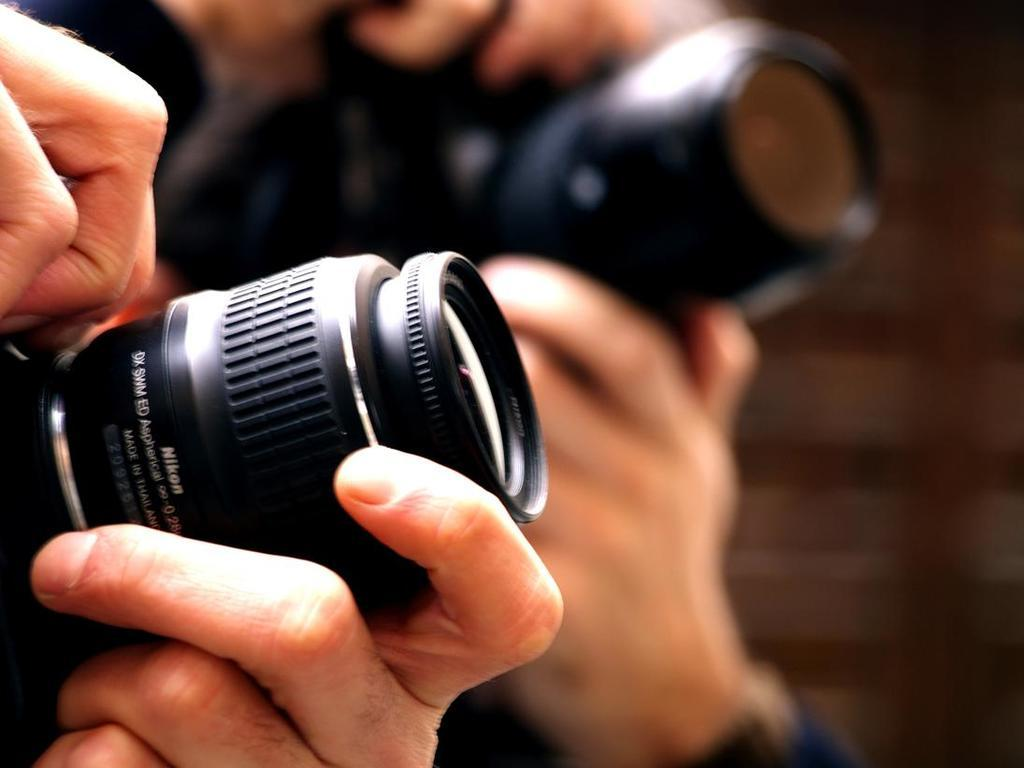How many people are present in the image? There are two people in the image. What are the people holding in their hands? The people are holding cameras in their hands. Can you describe the background of the image? The background of the image is blurred. What type of hook can be seen in the image? There is no hook present in the image. What is the people using their tongues for in the image? There is no indication in the image that the people are using their tongues for any purpose. 